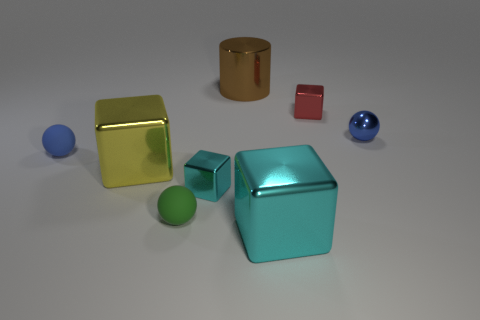Subtract all small matte spheres. How many spheres are left? 1 Add 2 blue balls. How many objects exist? 10 Subtract all green spheres. How many spheres are left? 2 Subtract 3 cubes. How many cubes are left? 1 Subtract all blue cubes. Subtract all red balls. How many cubes are left? 4 Subtract all cyan cylinders. How many brown spheres are left? 0 Subtract all small rubber objects. Subtract all blue things. How many objects are left? 4 Add 6 yellow shiny blocks. How many yellow shiny blocks are left? 7 Add 6 gray blocks. How many gray blocks exist? 6 Subtract 0 brown blocks. How many objects are left? 8 